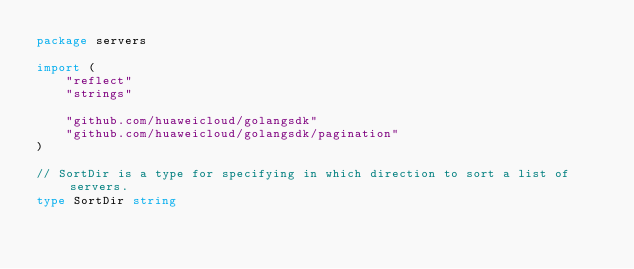Convert code to text. <code><loc_0><loc_0><loc_500><loc_500><_Go_>package servers

import (
	"reflect"
	"strings"

	"github.com/huaweicloud/golangsdk"
	"github.com/huaweicloud/golangsdk/pagination"
)

// SortDir is a type for specifying in which direction to sort a list of servers.
type SortDir string
</code> 